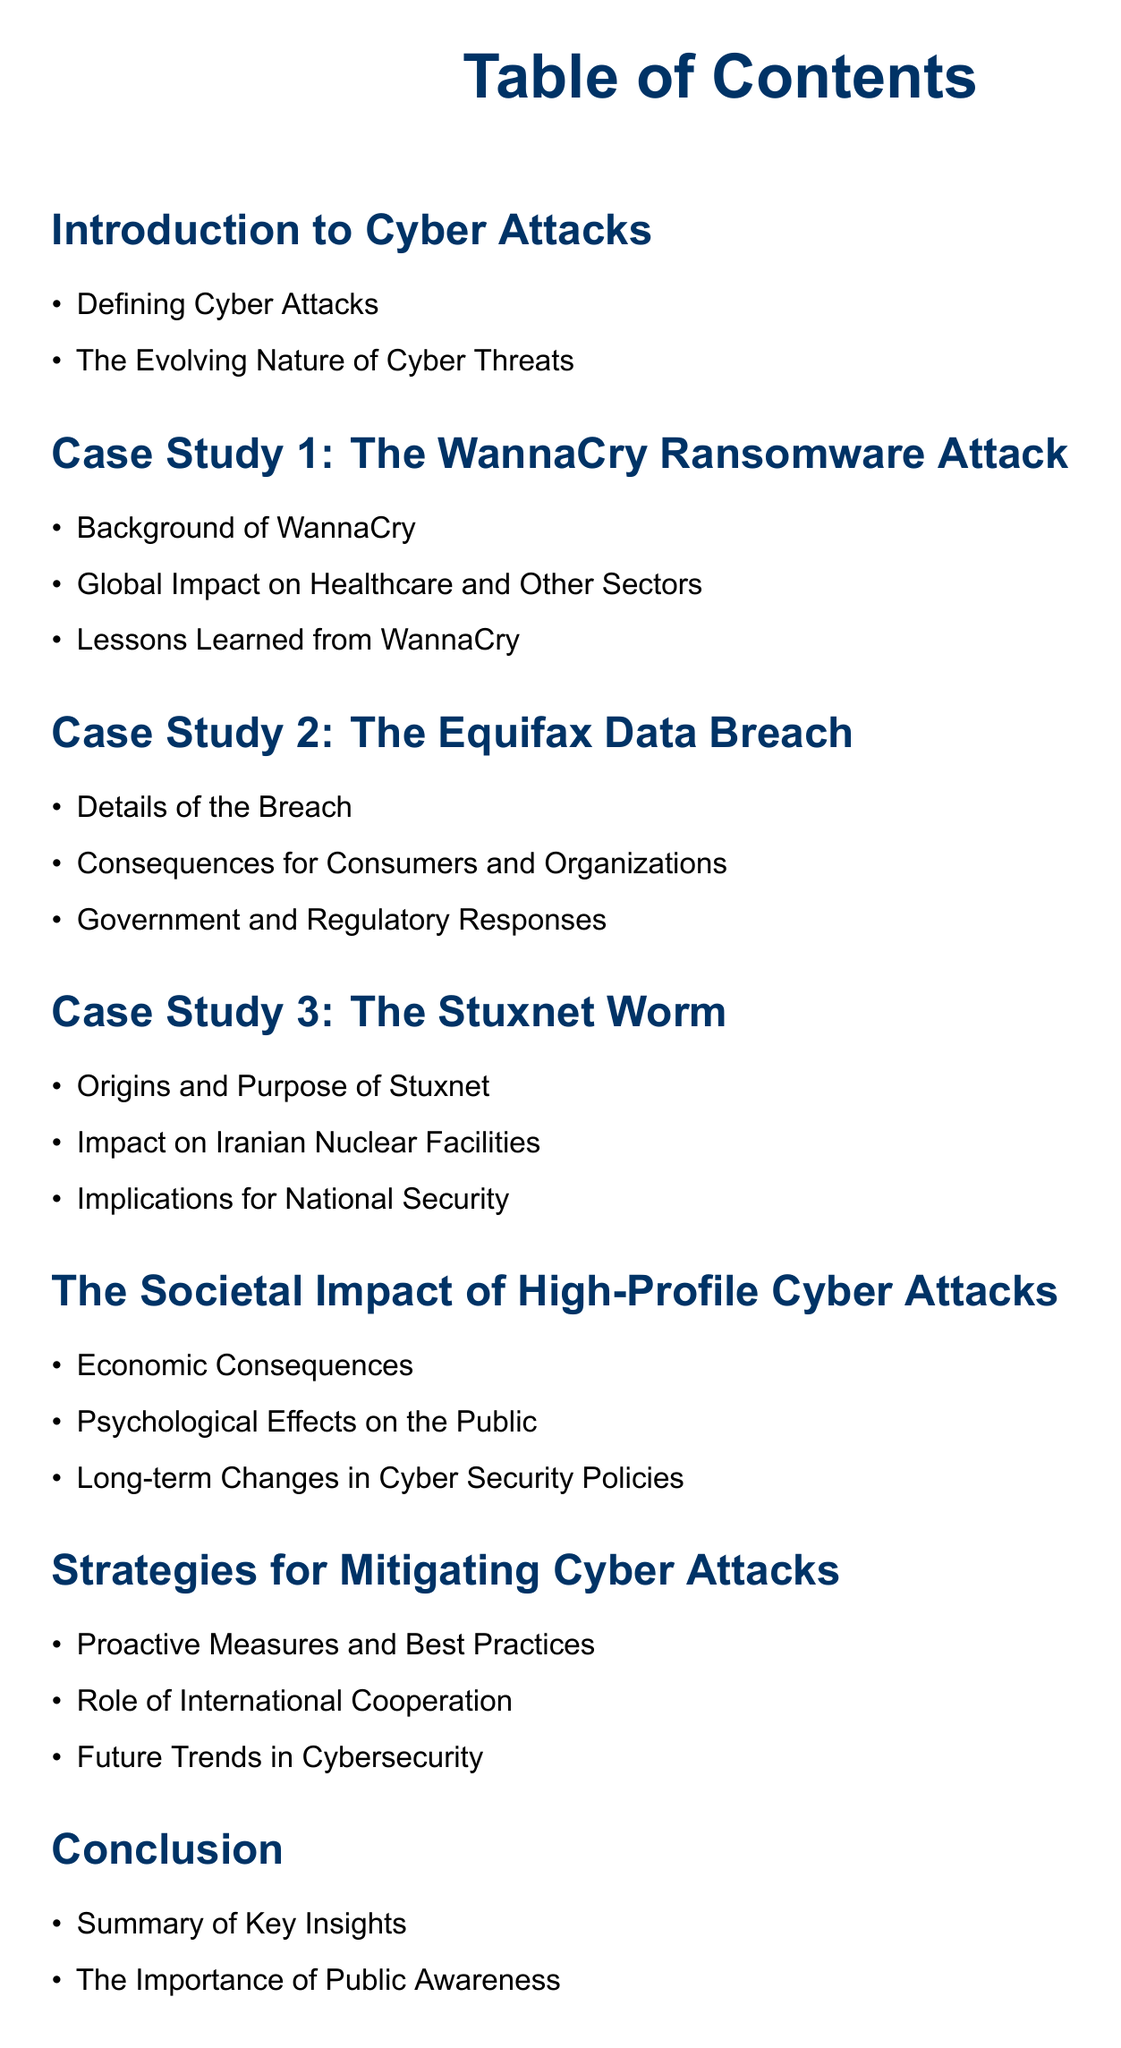What is the title of the first case study? The title of the first case study is listed under the section for case studies, which is "The WannaCry Ransomware Attack."
Answer: The WannaCry Ransomware Attack What immediate sector was impacted by the WannaCry attack? The document mentions the global impact of WannaCry on multiple sectors, specifically highlighting healthcare.
Answer: Healthcare What are the three main sections under the Equifax Data Breach case study? The document specifies the sections as: Details of the Breach, Consequences for Consumers and Organizations, and Government and Regulatory Responses.
Answer: Details of the Breach, Consequences for Consumers and Organizations, Government and Regulatory Responses How many total case studies are presented in the document? The document explicitly states three case studies, each under a distinct section.
Answer: Three What aspect of society is discussed in the section titled "The Societal Impact of High-Profile Cyber Attacks"? This section covers the effects of cyber attacks on society, focusing on Economic Consequences, Psychological Effects on the Public, and Long-term Changes in Cyber Security Policies.
Answer: Economic Consequences Which case study discusses implications for national security? The document highlights implications for national security in relation to the Stuxnet Worm case study.
Answer: The Stuxnet Worm What final theme is emphasized in the conclusion section? The conclusion section summarizes key insights and emphasizes the importance of maintaining public awareness regarding cyber attacks.
Answer: The Importance of Public Awareness Which section addresses future trends in cybersecurity? The section titled "Strategies for Mitigating Cyber Attacks" discusses proactive measures, international cooperation, and future trends in cybersecurity.
Answer: Future Trends in Cybersecurity 